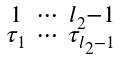<formula> <loc_0><loc_0><loc_500><loc_500>\begin{smallmatrix} 1 & \cdots & l _ { 2 } - 1 \\ \tau _ { 1 } & \cdots & \tau _ { l _ { 2 } - 1 } \end{smallmatrix}</formula> 